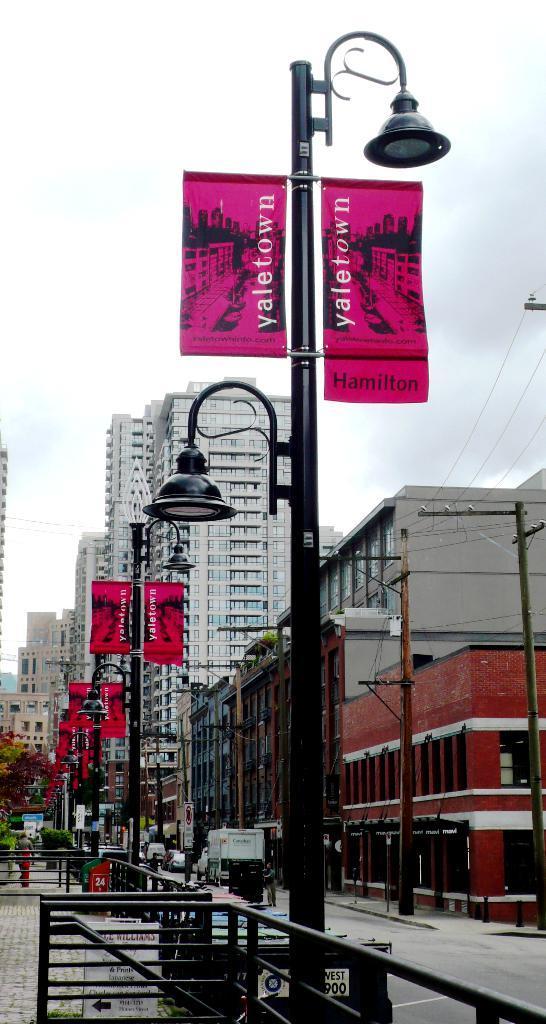Describe this image in one or two sentences. In this image in front there is a metal fence. There are street lights, banners, current polls. In the center of the image there is a road. In the background of the image there are trees, buildings and sky. 